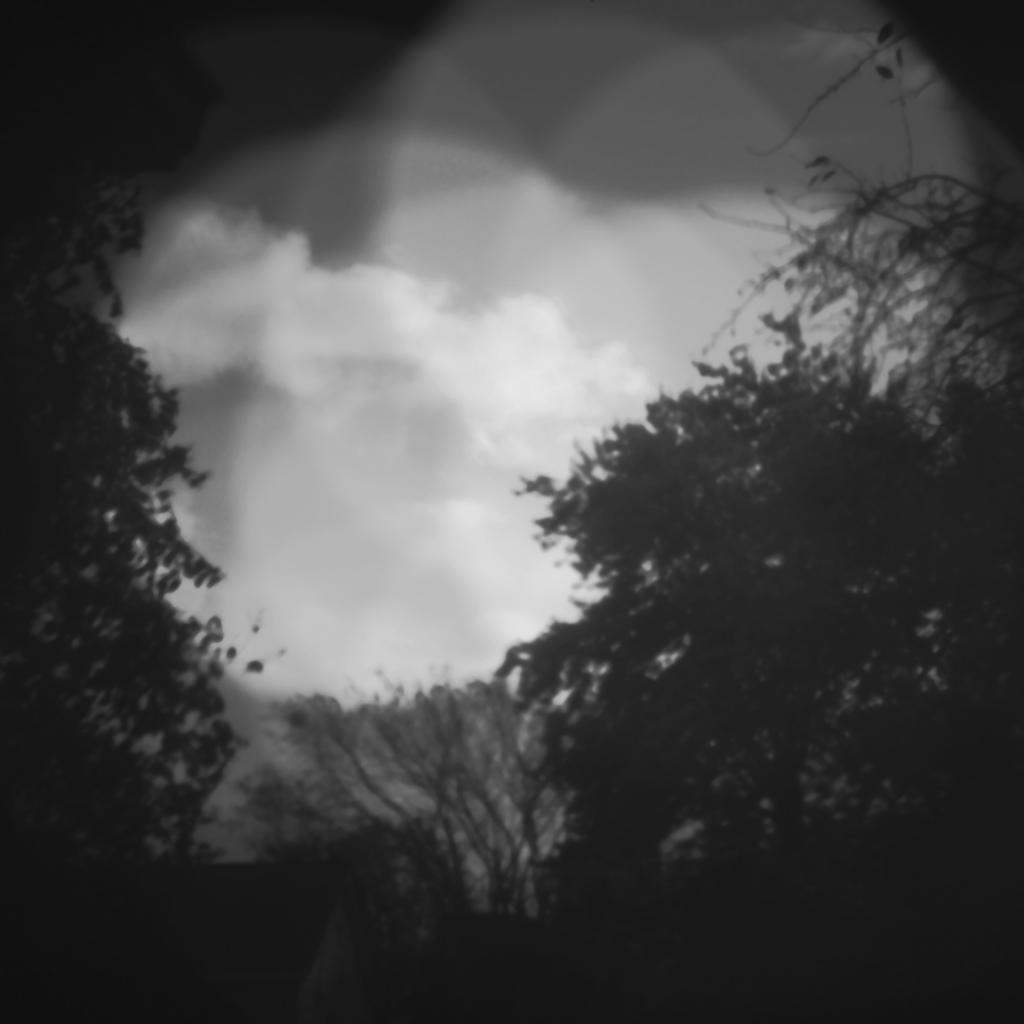Please provide a concise description of this image. This is a black and white image. In the image there are trees and also there is sky with clouds. 